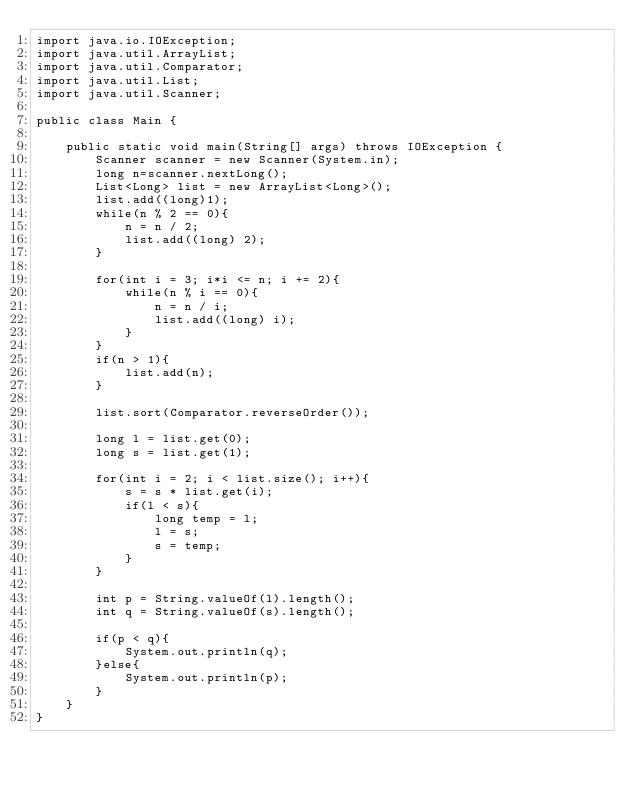<code> <loc_0><loc_0><loc_500><loc_500><_Java_>import java.io.IOException;
import java.util.ArrayList;
import java.util.Comparator;
import java.util.List;
import java.util.Scanner;

public class Main {

	public static void main(String[] args) throws IOException {
		Scanner scanner = new Scanner(System.in);
		long n=scanner.nextLong();
		List<Long> list = new ArrayList<Long>();
		list.add((long)1);
		while(n % 2 == 0){
			n = n / 2;
			list.add((long) 2);
		}

		for(int i = 3; i*i <= n; i += 2){
			while(n % i == 0){
				n = n / i;
				list.add((long) i);
			}
		}
		if(n > 1){
			list.add(n);
		}

		list.sort(Comparator.reverseOrder());

		long l = list.get(0);
		long s = list.get(1);

		for(int i = 2; i < list.size(); i++){
			s = s * list.get(i);
			if(l < s){
				long temp = l;
				l = s;
				s = temp;
			}
		}

		int p = String.valueOf(l).length();
		int q = String.valueOf(s).length();

		if(p < q){
			System.out.println(q);
		}else{
			System.out.println(p);
		}
	}
}</code> 